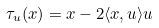<formula> <loc_0><loc_0><loc_500><loc_500>\tau _ { u } ( x ) = x - 2 \langle x , u \rangle u</formula> 